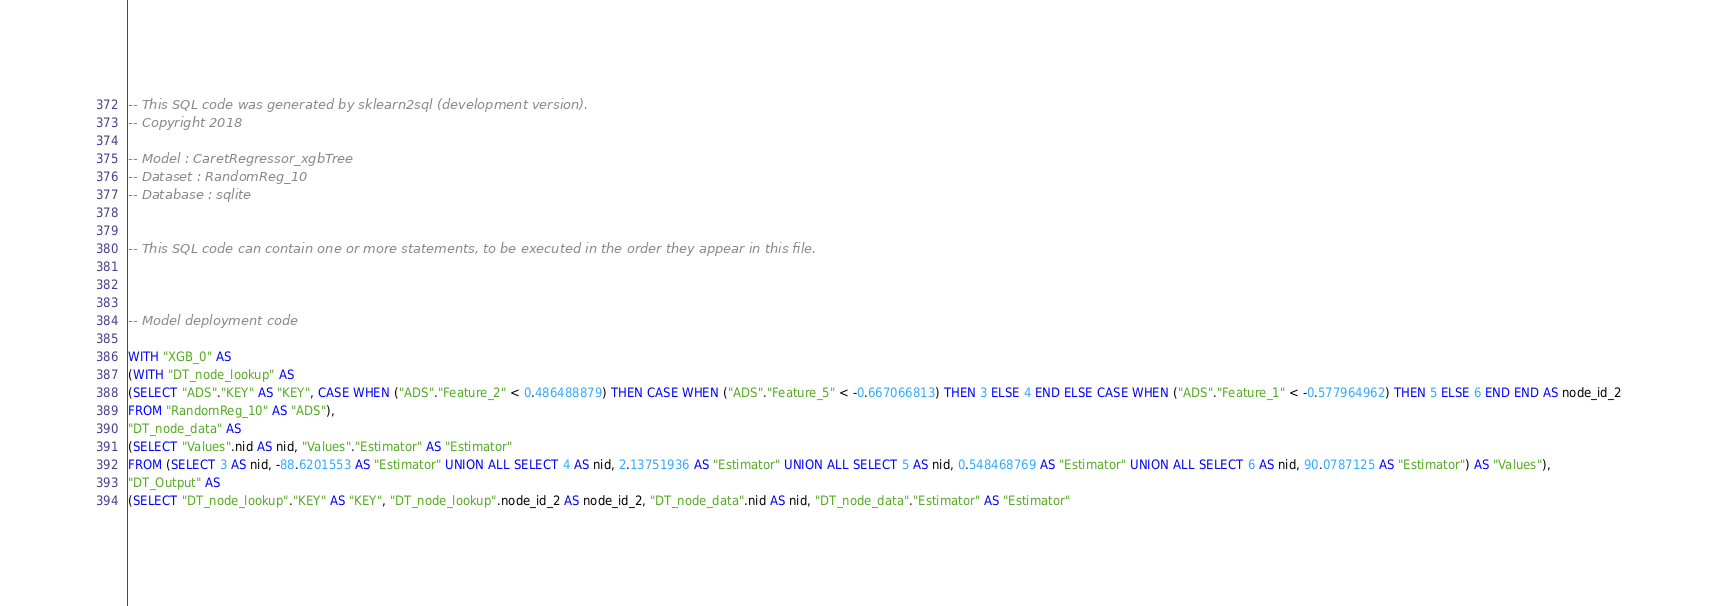Convert code to text. <code><loc_0><loc_0><loc_500><loc_500><_SQL_>-- This SQL code was generated by sklearn2sql (development version).
-- Copyright 2018

-- Model : CaretRegressor_xgbTree
-- Dataset : RandomReg_10
-- Database : sqlite


-- This SQL code can contain one or more statements, to be executed in the order they appear in this file.



-- Model deployment code

WITH "XGB_0" AS 
(WITH "DT_node_lookup" AS 
(SELECT "ADS"."KEY" AS "KEY", CASE WHEN ("ADS"."Feature_2" < 0.486488879) THEN CASE WHEN ("ADS"."Feature_5" < -0.667066813) THEN 3 ELSE 4 END ELSE CASE WHEN ("ADS"."Feature_1" < -0.577964962) THEN 5 ELSE 6 END END AS node_id_2 
FROM "RandomReg_10" AS "ADS"), 
"DT_node_data" AS 
(SELECT "Values".nid AS nid, "Values"."Estimator" AS "Estimator" 
FROM (SELECT 3 AS nid, -88.6201553 AS "Estimator" UNION ALL SELECT 4 AS nid, 2.13751936 AS "Estimator" UNION ALL SELECT 5 AS nid, 0.548468769 AS "Estimator" UNION ALL SELECT 6 AS nid, 90.0787125 AS "Estimator") AS "Values"), 
"DT_Output" AS 
(SELECT "DT_node_lookup"."KEY" AS "KEY", "DT_node_lookup".node_id_2 AS node_id_2, "DT_node_data".nid AS nid, "DT_node_data"."Estimator" AS "Estimator" </code> 